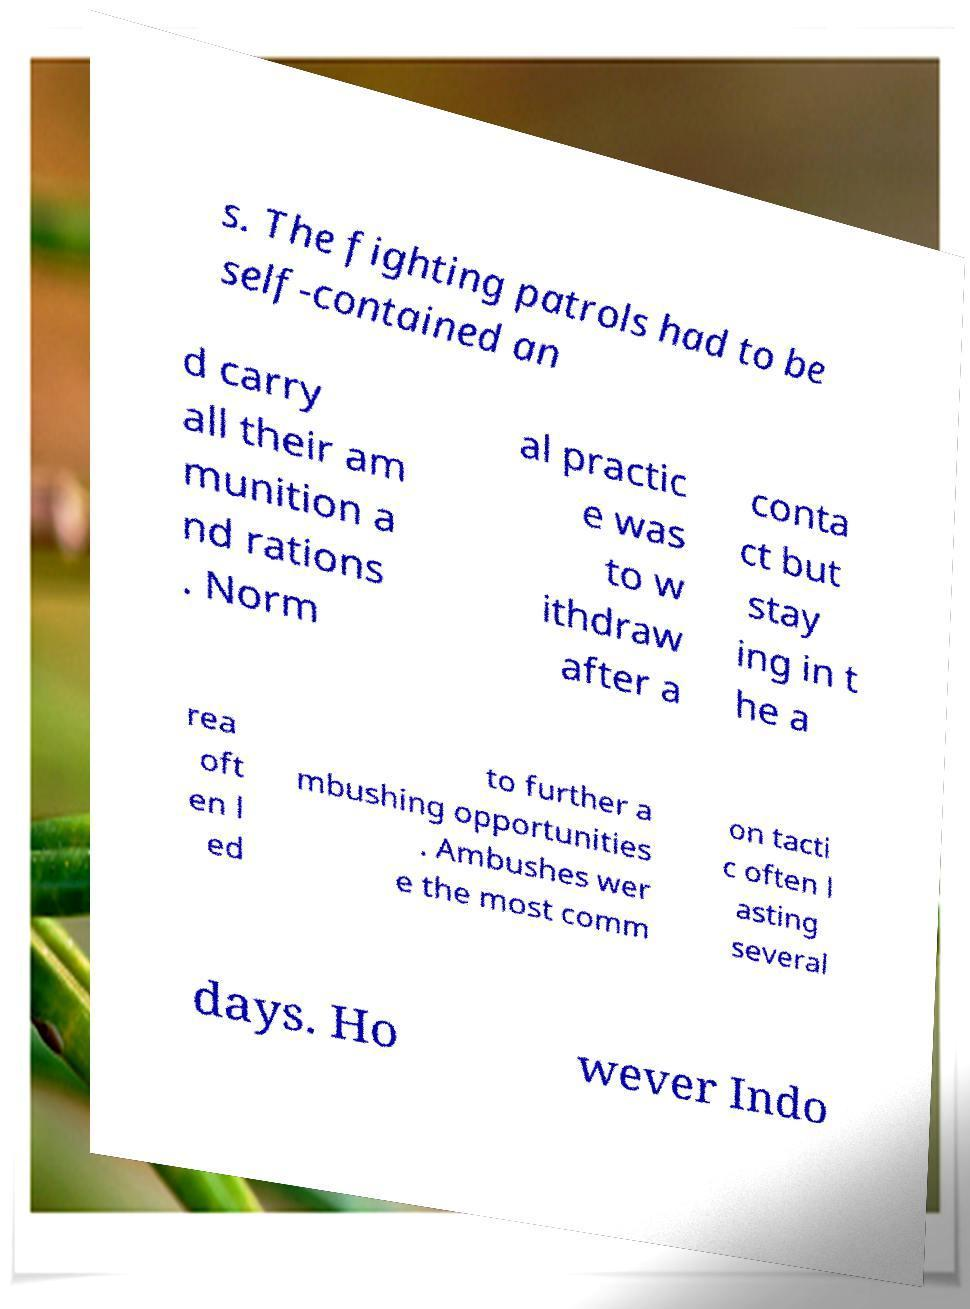Can you read and provide the text displayed in the image?This photo seems to have some interesting text. Can you extract and type it out for me? s. The fighting patrols had to be self-contained an d carry all their am munition a nd rations . Norm al practic e was to w ithdraw after a conta ct but stay ing in t he a rea oft en l ed to further a mbushing opportunities . Ambushes wer e the most comm on tacti c often l asting several days. Ho wever Indo 